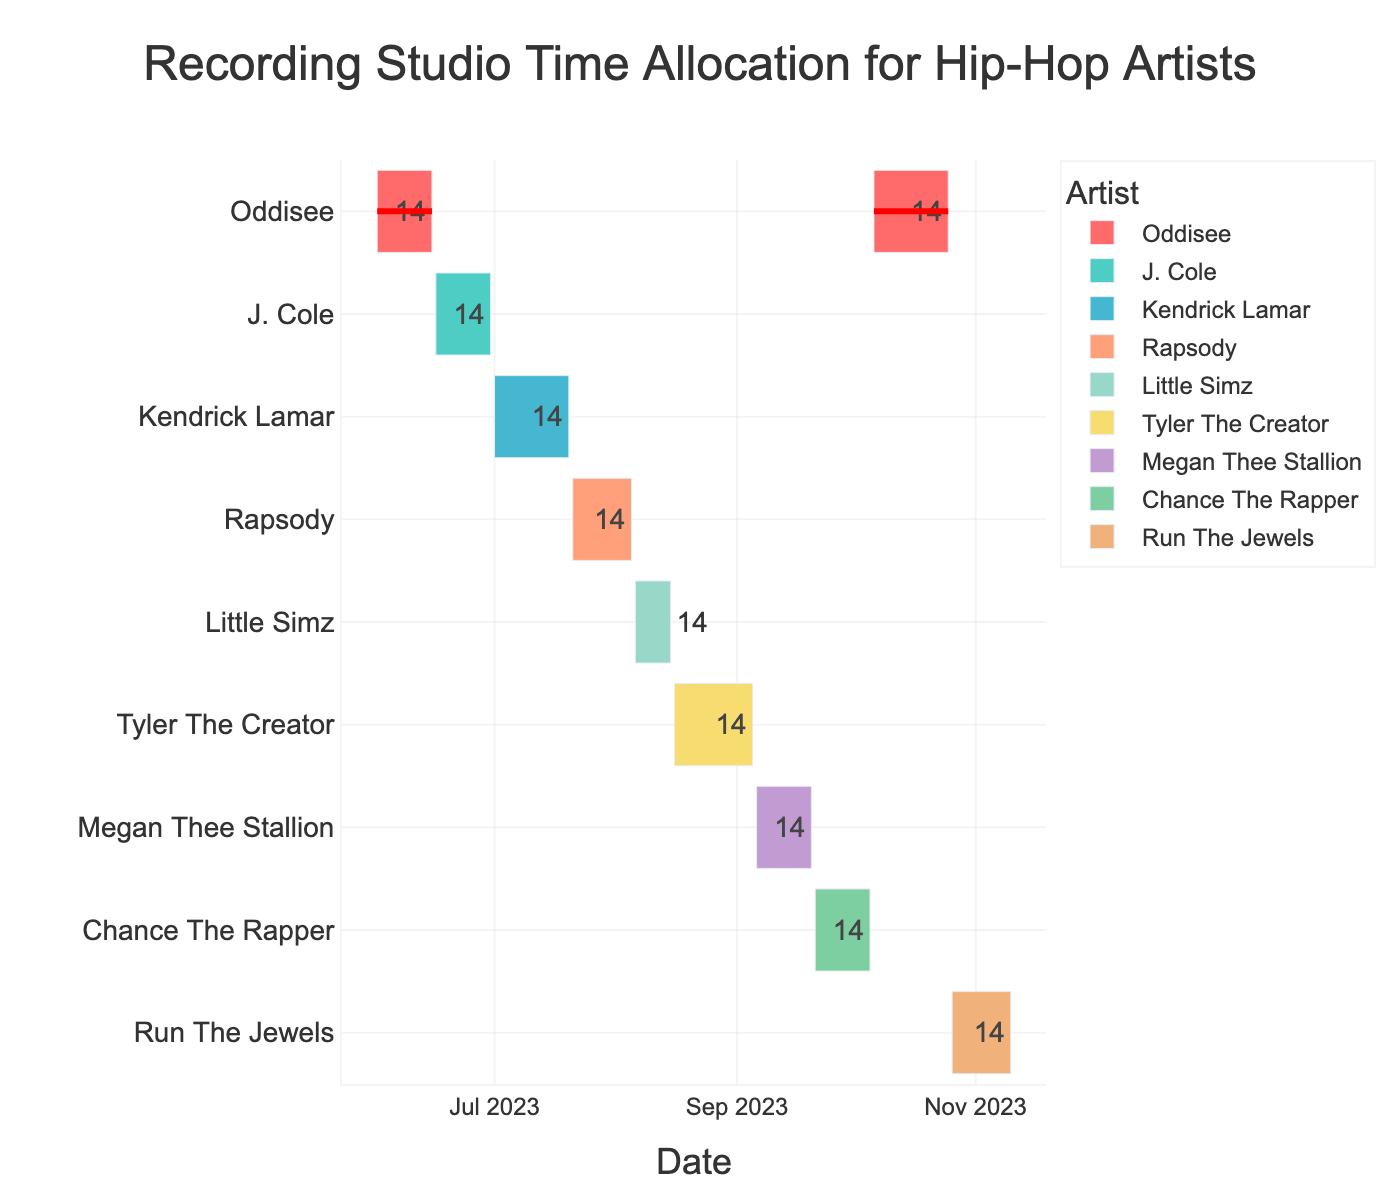How long is Oddisee's first recording session? Oddisee's first session is from June 1, 2023, to June 15, 2023. To find the duration, calculate the difference between the end date and start date: June 15, 2023 - June 1, 2023 = 15 days.
Answer: 15 days Which artist starts recording right after Oddisee's first session? J. Cole's recording session starts on June 16, 2023, which is immediately after Oddisee's first session ends on June 15, 2023.
Answer: J. Cole How many artists have recording sessions in July 2023? Both Kendrick Lamar and Rapsody have their recording sessions in July 2023. Kendrick Lamar's session spans from July 1 to July 20, and Rapsody's session spans from July 21 to August 5.
Answer: 2 artists What's the total recording time allocated to Tyler The Creator and Megan Thee Stallion? Tyler The Creator's session is from August 16 to September 5, which is 21 days. Megan Thee Stallion's session is from September 6 to September 20, which is 15 days. Adding them together results in 21 + 15 = 36 days.
Answer: 36 days Whose recording session lasts the longest? Tyler The Creator has the longest recording session, spanning from August 16, 2023, to September 5, 2023, which is 21 days. This is the longest compared to other sessions.
Answer: Tyler The Creator How many total recording days does Oddisee have across both sessions? Oddisee's first session is from June 1 to June 15 (15 days), and the second session is from October 6 to October 25 (20 days). Adding them together gives 15 + 20 = 35 days.
Answer: 35 days Who is recorded in the studio the earliest and who the latest? The earliest recording session starts with Oddisee on June 1, 2023, and the latest recording session ends with Run The Jewels on November 10, 2023.
Answer: Oddisee and Run The Jewels Which artist's recording session overlaps with Rapsody's session? Rapsody's session starts on July 21 and ends on August 5. Little Simz's session starts on August 6, right after Rapsody's session ends. There are no overlapping sessions with Rapsody.
Answer: None What is the total number of recording sessions scheduled? The Gantt chart shows recording sessions for 10 different time periods/artists.
Answer: 10 sessions Whose recording sessions are highlighted on the chart? Both of Oddisee's recording sessions are highlighted with a red outline in the Gantt chart.
Answer: Oddisee 